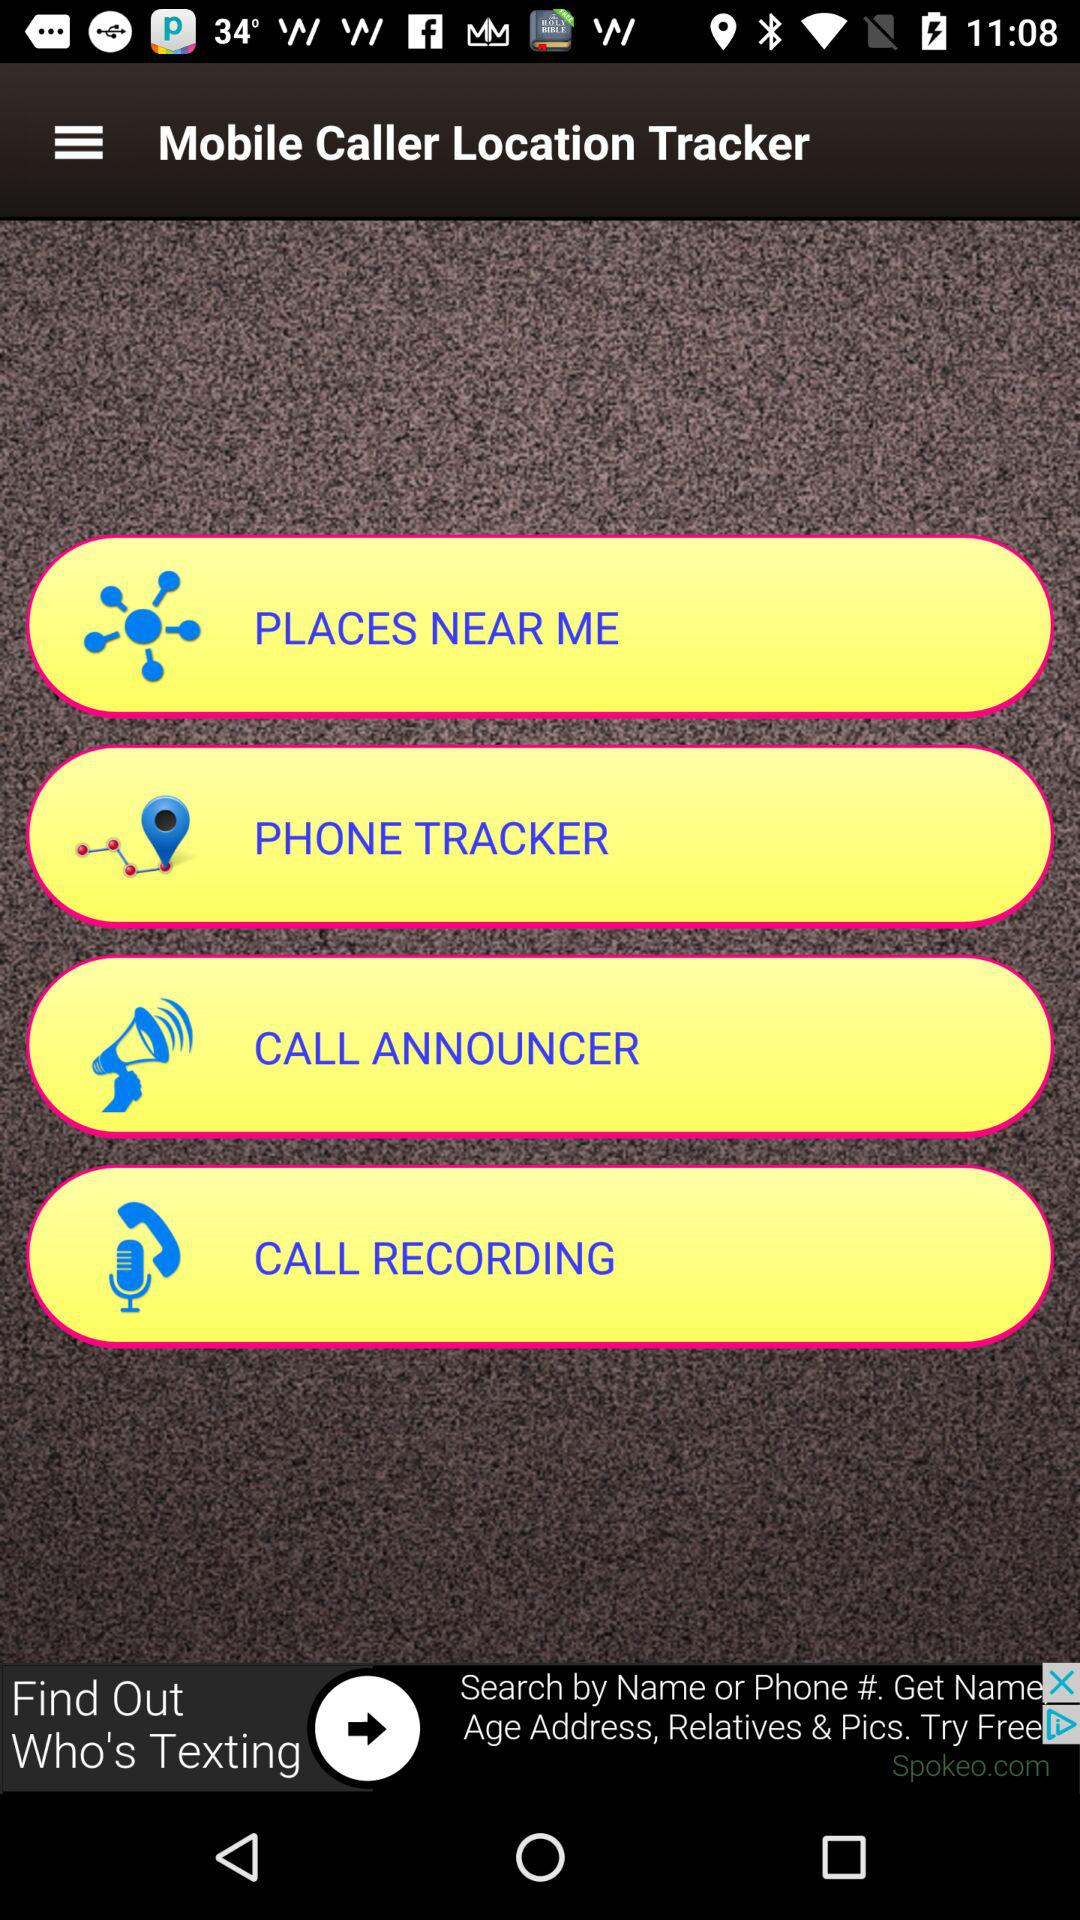What’s the app name? The app name is "Mobile Caller Location Tracker". 